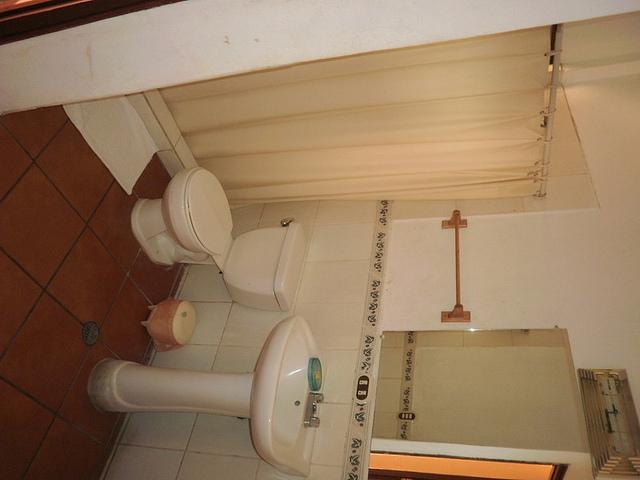What room is shown?
Keep it brief. Bathroom. What angle is this shot presented at?
Quick response, please. Sideways. What is next to the toilet?
Keep it brief. Sink. 